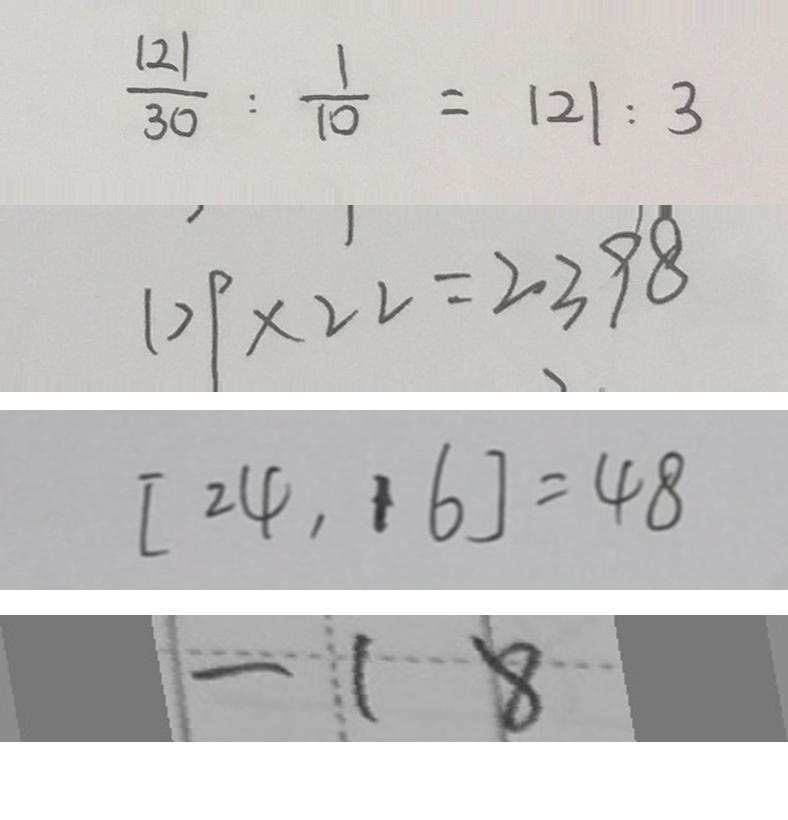Convert formula to latex. <formula><loc_0><loc_0><loc_500><loc_500>\frac { 1 2 1 } { 3 0 } : \frac { 1 } { 1 0 } = 1 2 1 : 3 
 1 0 9 \times 2 2 = 2 3 9 8 
 [ 2 4 , 1 6 ] = 4 8 
 - 1 8</formula> 